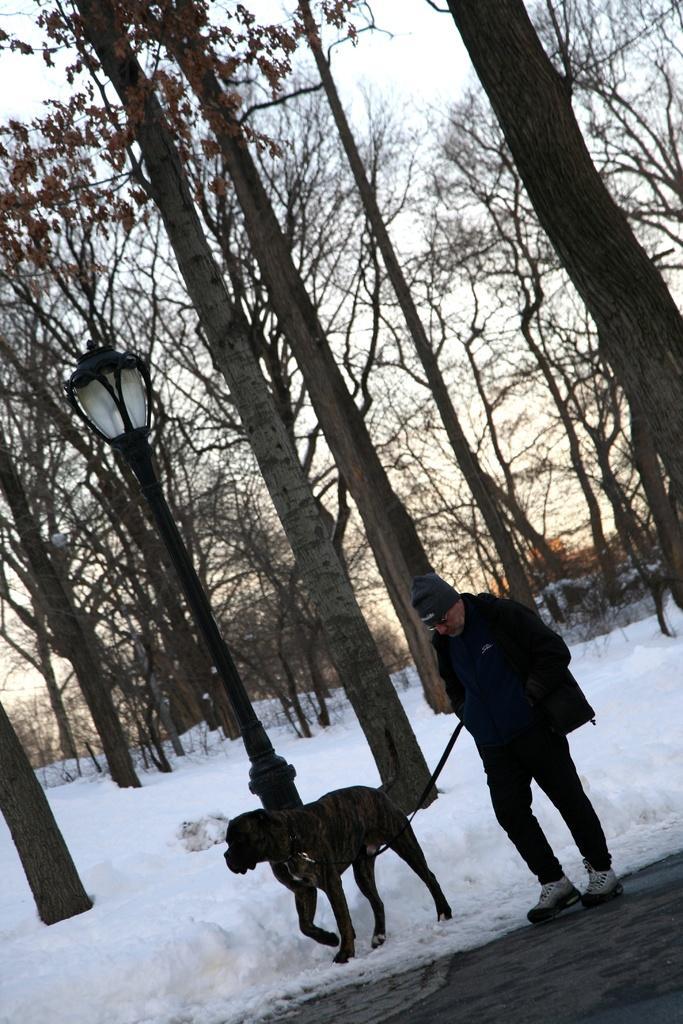Please provide a concise description of this image. In this picture, it is clicked outside a city. In this picture we can see snow. On the center of the picture there is a man going for walk with a dog. In the center there is a street light. There are many trees in the background. Sky is clear and visible. 